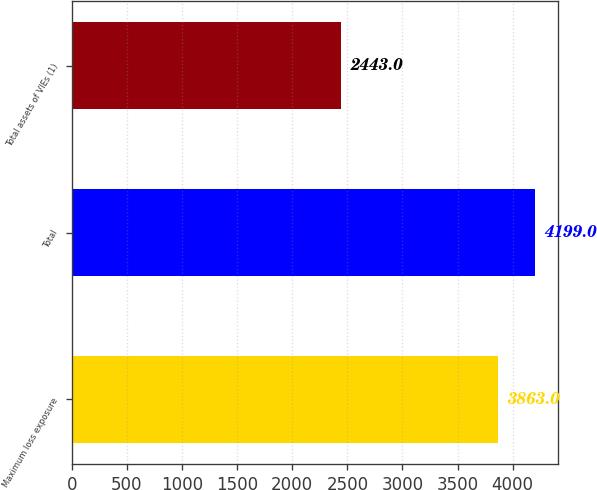<chart> <loc_0><loc_0><loc_500><loc_500><bar_chart><fcel>Maximum loss exposure<fcel>Total<fcel>Total assets of VIEs (1)<nl><fcel>3863<fcel>4199<fcel>2443<nl></chart> 